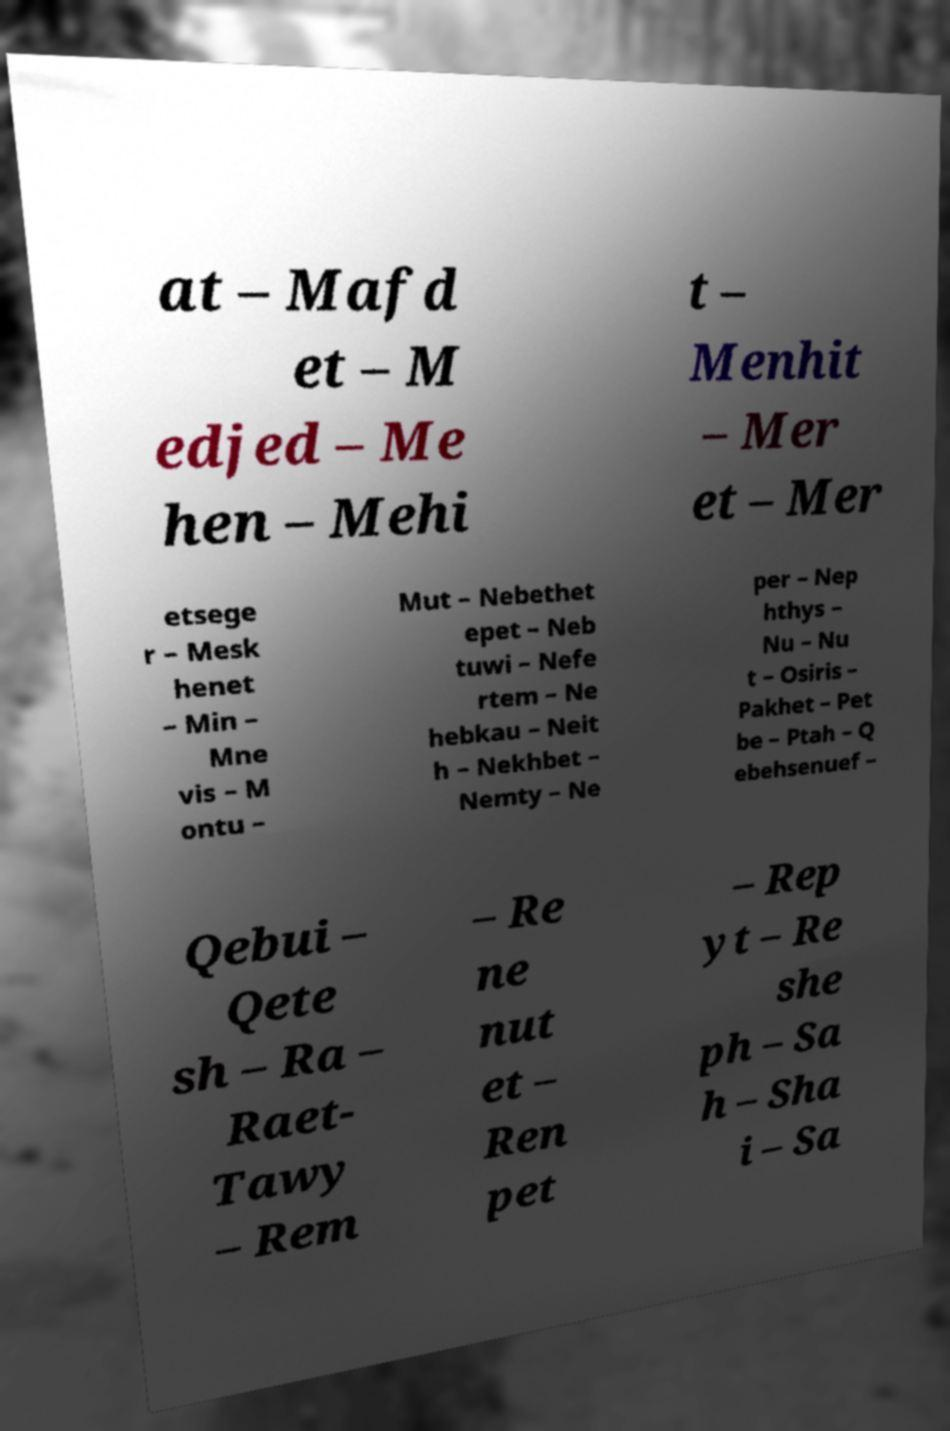What messages or text are displayed in this image? I need them in a readable, typed format. at – Mafd et – M edjed – Me hen – Mehi t – Menhit – Mer et – Mer etsege r – Mesk henet – Min – Mne vis – M ontu – Mut – Nebethet epet – Neb tuwi – Nefe rtem – Ne hebkau – Neit h – Nekhbet – Nemty – Ne per – Nep hthys – Nu – Nu t – Osiris – Pakhet – Pet be – Ptah – Q ebehsenuef – Qebui – Qete sh – Ra – Raet- Tawy – Rem – Re ne nut et – Ren pet – Rep yt – Re she ph – Sa h – Sha i – Sa 